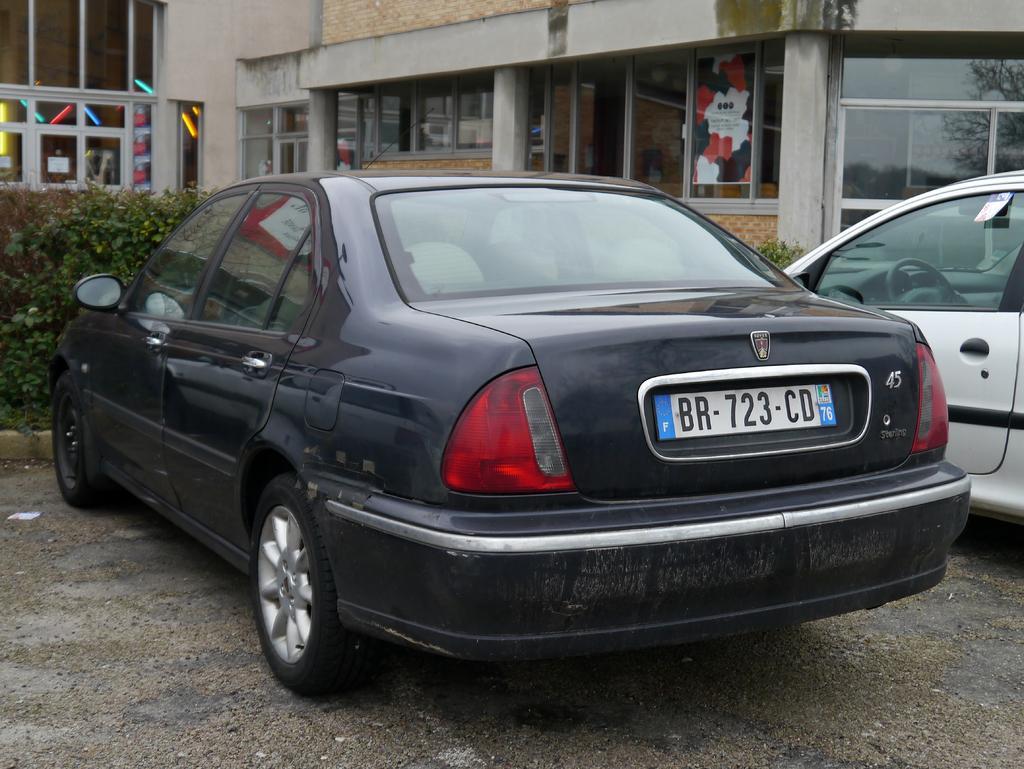Describe this image in one or two sentences. In this image there is a building with glass windows and walls, on the glass walls there are some posters. In front of the building there are are bushes, in front of the bushes there are cars parked. 